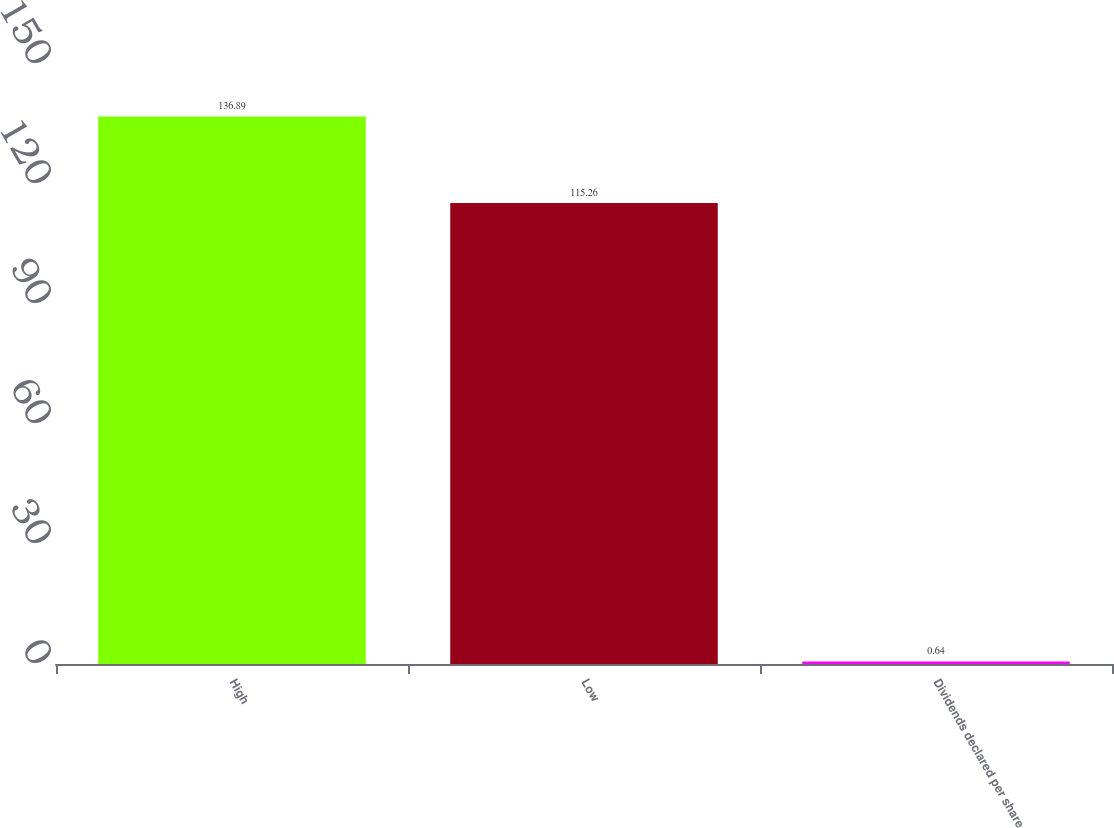Convert chart. <chart><loc_0><loc_0><loc_500><loc_500><bar_chart><fcel>High<fcel>Low<fcel>Dividends declared per share<nl><fcel>136.89<fcel>115.26<fcel>0.64<nl></chart> 